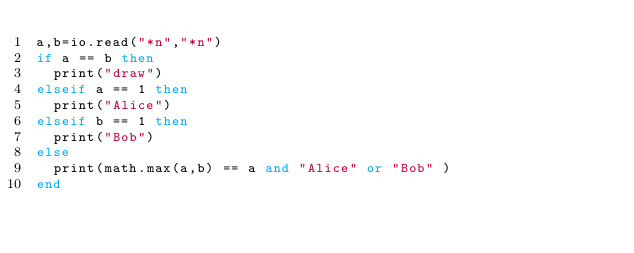<code> <loc_0><loc_0><loc_500><loc_500><_Lua_>a,b=io.read("*n","*n")
if a == b then
  print("draw")
elseif a == 1 then
  print("Alice")
elseif b == 1 then
  print("Bob")
else
  print(math.max(a,b) == a and "Alice" or "Bob" )
end</code> 